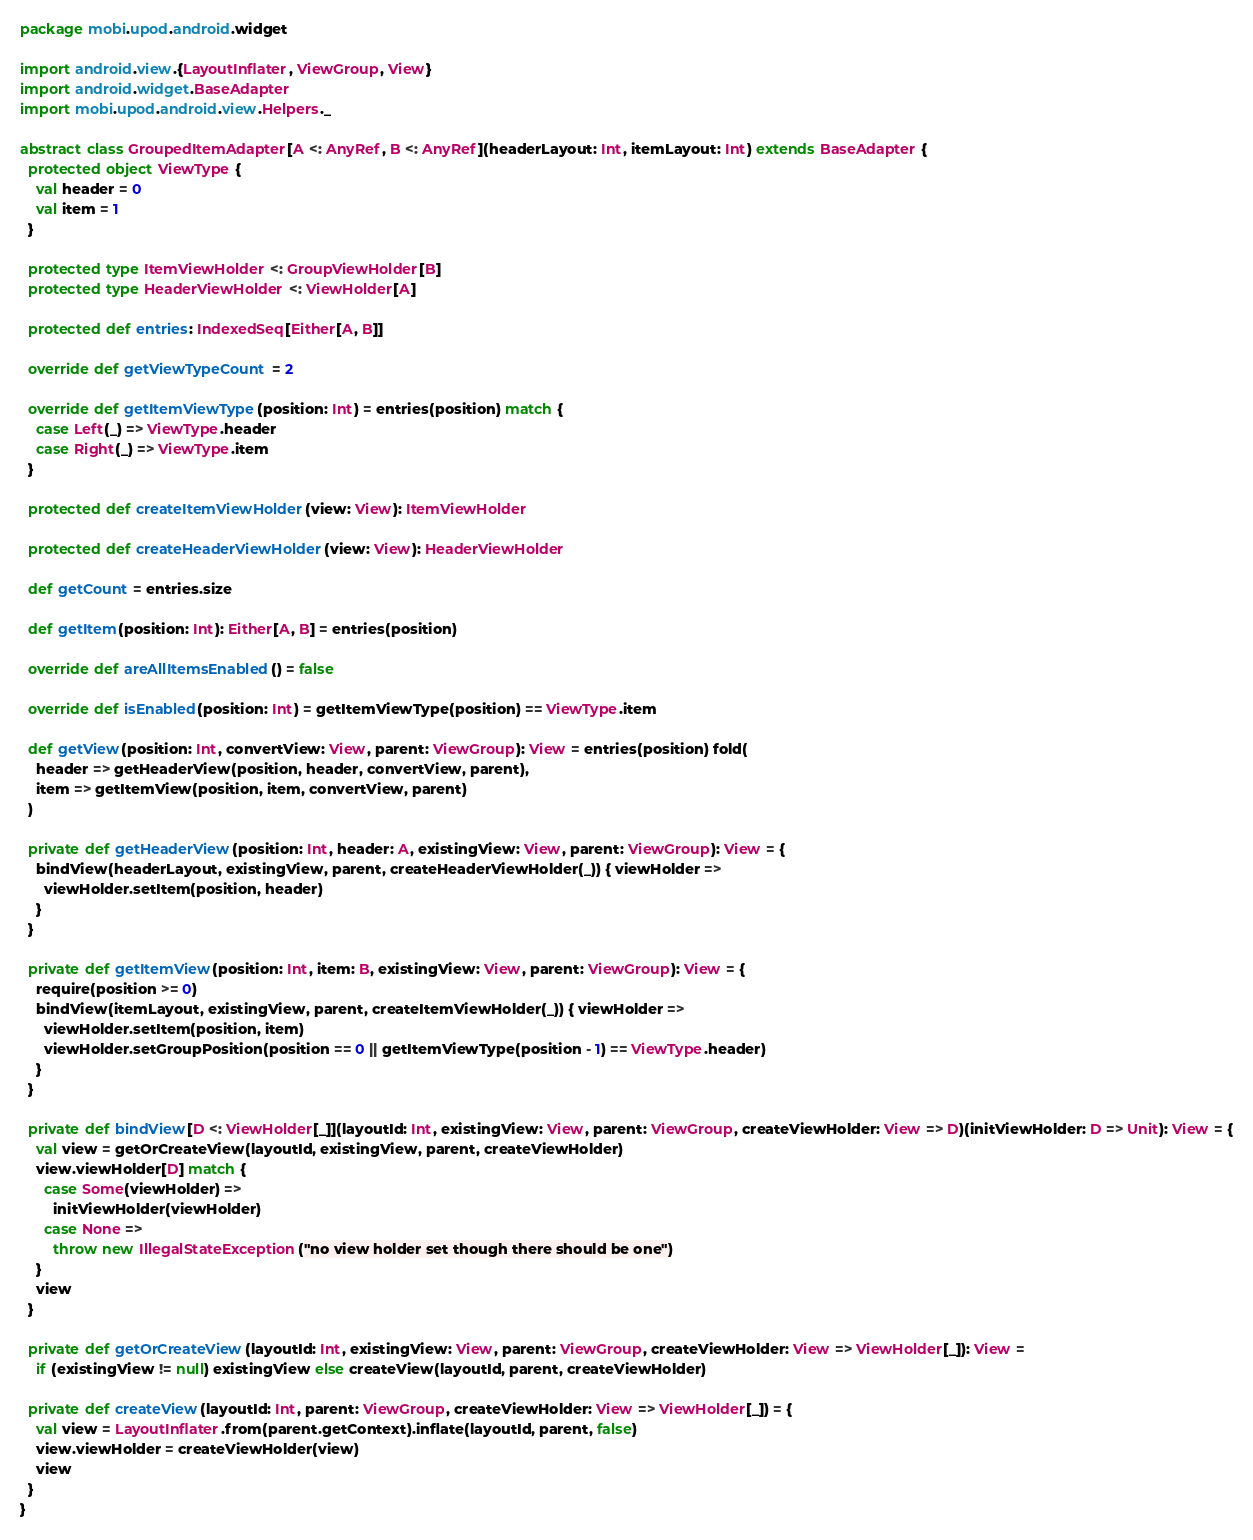<code> <loc_0><loc_0><loc_500><loc_500><_Scala_>package mobi.upod.android.widget

import android.view.{LayoutInflater, ViewGroup, View}
import android.widget.BaseAdapter
import mobi.upod.android.view.Helpers._

abstract class GroupedItemAdapter[A <: AnyRef, B <: AnyRef](headerLayout: Int, itemLayout: Int) extends BaseAdapter {
  protected object ViewType {
    val header = 0
    val item = 1
  }

  protected type ItemViewHolder <: GroupViewHolder[B]
  protected type HeaderViewHolder <: ViewHolder[A]

  protected def entries: IndexedSeq[Either[A, B]]

  override def getViewTypeCount = 2

  override def getItemViewType(position: Int) = entries(position) match {
    case Left(_) => ViewType.header
    case Right(_) => ViewType.item
  }

  protected def createItemViewHolder(view: View): ItemViewHolder

  protected def createHeaderViewHolder(view: View): HeaderViewHolder

  def getCount = entries.size

  def getItem(position: Int): Either[A, B] = entries(position)

  override def areAllItemsEnabled() = false

  override def isEnabled(position: Int) = getItemViewType(position) == ViewType.item

  def getView(position: Int, convertView: View, parent: ViewGroup): View = entries(position) fold(
    header => getHeaderView(position, header, convertView, parent),
    item => getItemView(position, item, convertView, parent)
  )

  private def getHeaderView(position: Int, header: A, existingView: View, parent: ViewGroup): View = {
    bindView(headerLayout, existingView, parent, createHeaderViewHolder(_)) { viewHolder =>
      viewHolder.setItem(position, header)
    }
  }

  private def getItemView(position: Int, item: B, existingView: View, parent: ViewGroup): View = {
    require(position >= 0)
    bindView(itemLayout, existingView, parent, createItemViewHolder(_)) { viewHolder =>
      viewHolder.setItem(position, item)
      viewHolder.setGroupPosition(position == 0 || getItemViewType(position - 1) == ViewType.header)
    }
  }

  private def bindView[D <: ViewHolder[_]](layoutId: Int, existingView: View, parent: ViewGroup, createViewHolder: View => D)(initViewHolder: D => Unit): View = {
    val view = getOrCreateView(layoutId, existingView, parent, createViewHolder)
    view.viewHolder[D] match {
      case Some(viewHolder) =>
        initViewHolder(viewHolder)
      case None =>
        throw new IllegalStateException("no view holder set though there should be one")
    }
    view
  }

  private def getOrCreateView(layoutId: Int, existingView: View, parent: ViewGroup, createViewHolder: View => ViewHolder[_]): View =
    if (existingView != null) existingView else createView(layoutId, parent, createViewHolder)

  private def createView(layoutId: Int, parent: ViewGroup, createViewHolder: View => ViewHolder[_]) = {
    val view = LayoutInflater.from(parent.getContext).inflate(layoutId, parent, false)
    view.viewHolder = createViewHolder(view)
    view
  }
}
</code> 